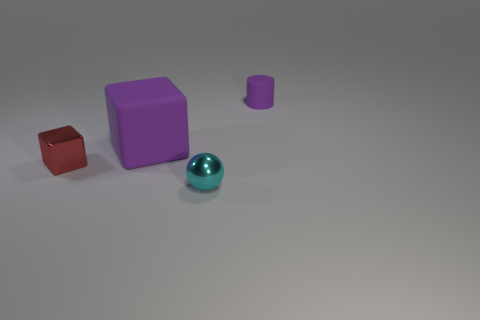Add 2 cyan shiny things. How many objects exist? 6 Subtract 0 red spheres. How many objects are left? 4 Subtract all cylinders. How many objects are left? 3 Subtract all brown blocks. Subtract all cyan cylinders. How many blocks are left? 2 Subtract all yellow balls. How many purple cubes are left? 1 Subtract all small matte cylinders. Subtract all tiny cyan shiny balls. How many objects are left? 2 Add 1 purple matte things. How many purple matte things are left? 3 Add 2 yellow shiny cylinders. How many yellow shiny cylinders exist? 2 